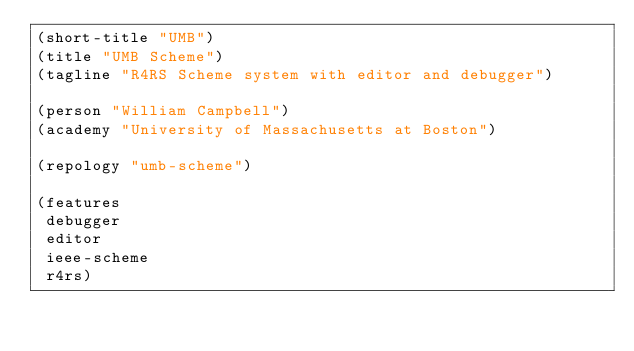<code> <loc_0><loc_0><loc_500><loc_500><_Scheme_>(short-title "UMB")
(title "UMB Scheme")
(tagline "R4RS Scheme system with editor and debugger")

(person "William Campbell")
(academy "University of Massachusetts at Boston")

(repology "umb-scheme")

(features
 debugger
 editor
 ieee-scheme
 r4rs)
</code> 